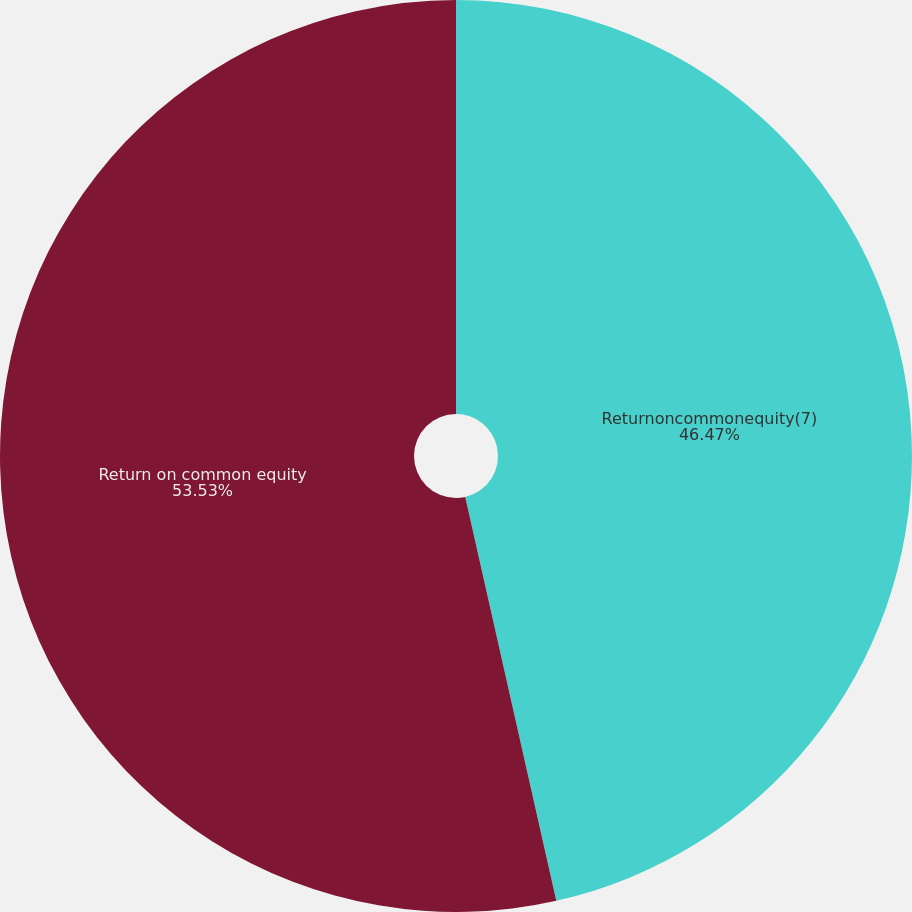Convert chart to OTSL. <chart><loc_0><loc_0><loc_500><loc_500><pie_chart><fcel>Returnoncommonequity(7)<fcel>Return on common equity<nl><fcel>46.47%<fcel>53.53%<nl></chart> 